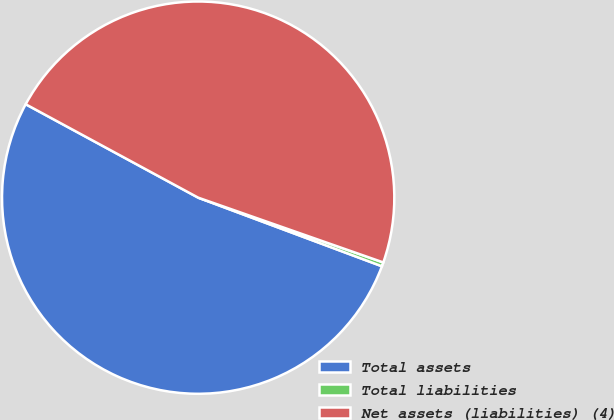<chart> <loc_0><loc_0><loc_500><loc_500><pie_chart><fcel>Total assets<fcel>Total liabilities<fcel>Net assets (liabilities) (4)<nl><fcel>52.21%<fcel>0.33%<fcel>47.46%<nl></chart> 